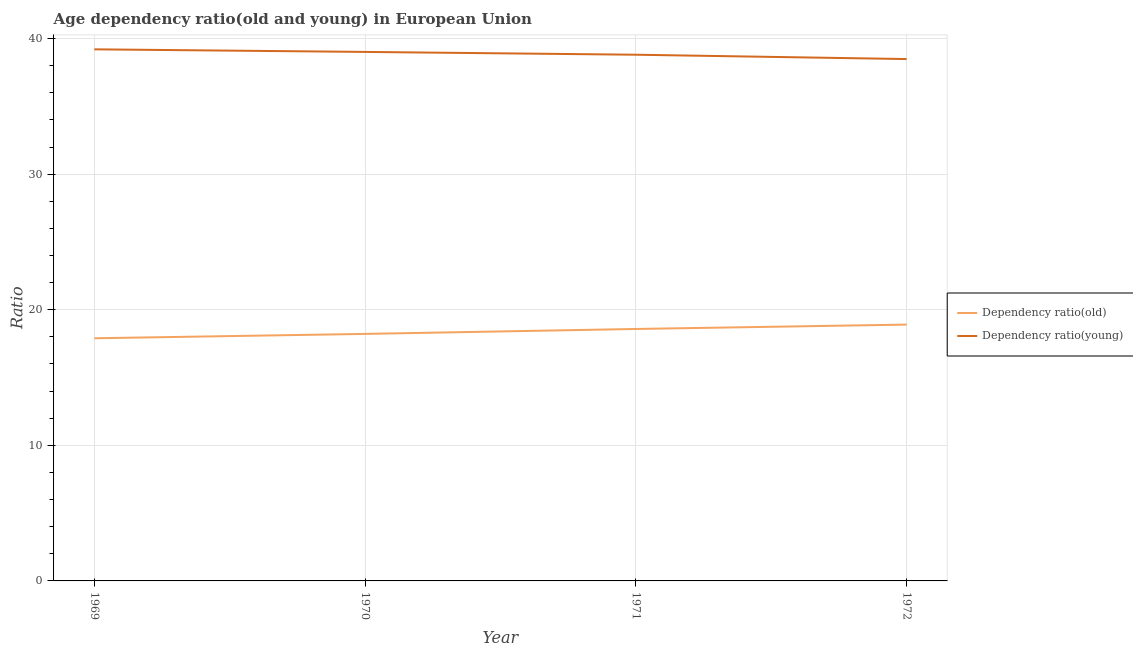Is the number of lines equal to the number of legend labels?
Your response must be concise. Yes. What is the age dependency ratio(old) in 1971?
Ensure brevity in your answer.  18.58. Across all years, what is the maximum age dependency ratio(young)?
Offer a very short reply. 39.21. Across all years, what is the minimum age dependency ratio(old)?
Provide a short and direct response. 17.9. In which year was the age dependency ratio(young) maximum?
Your answer should be very brief. 1969. In which year was the age dependency ratio(old) minimum?
Provide a short and direct response. 1969. What is the total age dependency ratio(old) in the graph?
Provide a succinct answer. 73.6. What is the difference between the age dependency ratio(old) in 1969 and that in 1970?
Offer a very short reply. -0.32. What is the difference between the age dependency ratio(old) in 1972 and the age dependency ratio(young) in 1970?
Give a very brief answer. -20.11. What is the average age dependency ratio(young) per year?
Keep it short and to the point. 38.88. In the year 1972, what is the difference between the age dependency ratio(old) and age dependency ratio(young)?
Give a very brief answer. -19.59. In how many years, is the age dependency ratio(young) greater than 4?
Provide a short and direct response. 4. What is the ratio of the age dependency ratio(old) in 1971 to that in 1972?
Keep it short and to the point. 0.98. Is the difference between the age dependency ratio(old) in 1969 and 1972 greater than the difference between the age dependency ratio(young) in 1969 and 1972?
Your answer should be compact. No. What is the difference between the highest and the second highest age dependency ratio(young)?
Offer a terse response. 0.19. What is the difference between the highest and the lowest age dependency ratio(young)?
Your answer should be compact. 0.72. Is the sum of the age dependency ratio(old) in 1971 and 1972 greater than the maximum age dependency ratio(young) across all years?
Offer a very short reply. No. Does the age dependency ratio(old) monotonically increase over the years?
Offer a terse response. Yes. Is the age dependency ratio(young) strictly greater than the age dependency ratio(old) over the years?
Make the answer very short. Yes. How many years are there in the graph?
Ensure brevity in your answer.  4. What is the difference between two consecutive major ticks on the Y-axis?
Make the answer very short. 10. Where does the legend appear in the graph?
Your answer should be compact. Center right. How many legend labels are there?
Make the answer very short. 2. What is the title of the graph?
Your answer should be very brief. Age dependency ratio(old and young) in European Union. What is the label or title of the Y-axis?
Offer a very short reply. Ratio. What is the Ratio in Dependency ratio(old) in 1969?
Your answer should be very brief. 17.9. What is the Ratio in Dependency ratio(young) in 1969?
Offer a terse response. 39.21. What is the Ratio in Dependency ratio(old) in 1970?
Make the answer very short. 18.22. What is the Ratio in Dependency ratio(young) in 1970?
Keep it short and to the point. 39.02. What is the Ratio of Dependency ratio(old) in 1971?
Make the answer very short. 18.58. What is the Ratio in Dependency ratio(young) in 1971?
Your answer should be very brief. 38.81. What is the Ratio in Dependency ratio(old) in 1972?
Make the answer very short. 18.91. What is the Ratio in Dependency ratio(young) in 1972?
Provide a succinct answer. 38.49. Across all years, what is the maximum Ratio of Dependency ratio(old)?
Make the answer very short. 18.91. Across all years, what is the maximum Ratio of Dependency ratio(young)?
Give a very brief answer. 39.21. Across all years, what is the minimum Ratio of Dependency ratio(old)?
Offer a terse response. 17.9. Across all years, what is the minimum Ratio of Dependency ratio(young)?
Give a very brief answer. 38.49. What is the total Ratio in Dependency ratio(old) in the graph?
Make the answer very short. 73.6. What is the total Ratio of Dependency ratio(young) in the graph?
Ensure brevity in your answer.  155.53. What is the difference between the Ratio of Dependency ratio(old) in 1969 and that in 1970?
Give a very brief answer. -0.32. What is the difference between the Ratio in Dependency ratio(young) in 1969 and that in 1970?
Ensure brevity in your answer.  0.19. What is the difference between the Ratio of Dependency ratio(old) in 1969 and that in 1971?
Ensure brevity in your answer.  -0.69. What is the difference between the Ratio of Dependency ratio(young) in 1969 and that in 1971?
Offer a terse response. 0.4. What is the difference between the Ratio of Dependency ratio(old) in 1969 and that in 1972?
Offer a very short reply. -1.01. What is the difference between the Ratio in Dependency ratio(young) in 1969 and that in 1972?
Ensure brevity in your answer.  0.72. What is the difference between the Ratio of Dependency ratio(old) in 1970 and that in 1971?
Keep it short and to the point. -0.36. What is the difference between the Ratio in Dependency ratio(young) in 1970 and that in 1971?
Keep it short and to the point. 0.21. What is the difference between the Ratio in Dependency ratio(old) in 1970 and that in 1972?
Your answer should be very brief. -0.69. What is the difference between the Ratio of Dependency ratio(young) in 1970 and that in 1972?
Give a very brief answer. 0.53. What is the difference between the Ratio in Dependency ratio(old) in 1971 and that in 1972?
Give a very brief answer. -0.32. What is the difference between the Ratio of Dependency ratio(young) in 1971 and that in 1972?
Offer a very short reply. 0.32. What is the difference between the Ratio of Dependency ratio(old) in 1969 and the Ratio of Dependency ratio(young) in 1970?
Keep it short and to the point. -21.12. What is the difference between the Ratio of Dependency ratio(old) in 1969 and the Ratio of Dependency ratio(young) in 1971?
Give a very brief answer. -20.91. What is the difference between the Ratio in Dependency ratio(old) in 1969 and the Ratio in Dependency ratio(young) in 1972?
Your answer should be very brief. -20.59. What is the difference between the Ratio in Dependency ratio(old) in 1970 and the Ratio in Dependency ratio(young) in 1971?
Make the answer very short. -20.59. What is the difference between the Ratio in Dependency ratio(old) in 1970 and the Ratio in Dependency ratio(young) in 1972?
Your response must be concise. -20.27. What is the difference between the Ratio in Dependency ratio(old) in 1971 and the Ratio in Dependency ratio(young) in 1972?
Provide a short and direct response. -19.91. What is the average Ratio of Dependency ratio(old) per year?
Offer a very short reply. 18.4. What is the average Ratio of Dependency ratio(young) per year?
Ensure brevity in your answer.  38.88. In the year 1969, what is the difference between the Ratio of Dependency ratio(old) and Ratio of Dependency ratio(young)?
Your response must be concise. -21.31. In the year 1970, what is the difference between the Ratio of Dependency ratio(old) and Ratio of Dependency ratio(young)?
Provide a short and direct response. -20.8. In the year 1971, what is the difference between the Ratio of Dependency ratio(old) and Ratio of Dependency ratio(young)?
Your response must be concise. -20.23. In the year 1972, what is the difference between the Ratio in Dependency ratio(old) and Ratio in Dependency ratio(young)?
Your response must be concise. -19.59. What is the ratio of the Ratio of Dependency ratio(old) in 1969 to that in 1970?
Your answer should be compact. 0.98. What is the ratio of the Ratio of Dependency ratio(young) in 1969 to that in 1970?
Make the answer very short. 1. What is the ratio of the Ratio in Dependency ratio(old) in 1969 to that in 1971?
Your answer should be compact. 0.96. What is the ratio of the Ratio in Dependency ratio(young) in 1969 to that in 1971?
Your answer should be compact. 1.01. What is the ratio of the Ratio of Dependency ratio(old) in 1969 to that in 1972?
Your answer should be compact. 0.95. What is the ratio of the Ratio of Dependency ratio(young) in 1969 to that in 1972?
Give a very brief answer. 1.02. What is the ratio of the Ratio of Dependency ratio(old) in 1970 to that in 1971?
Offer a very short reply. 0.98. What is the ratio of the Ratio of Dependency ratio(old) in 1970 to that in 1972?
Your response must be concise. 0.96. What is the ratio of the Ratio in Dependency ratio(young) in 1970 to that in 1972?
Provide a short and direct response. 1.01. What is the ratio of the Ratio in Dependency ratio(old) in 1971 to that in 1972?
Provide a short and direct response. 0.98. What is the ratio of the Ratio in Dependency ratio(young) in 1971 to that in 1972?
Provide a succinct answer. 1.01. What is the difference between the highest and the second highest Ratio in Dependency ratio(old)?
Provide a short and direct response. 0.32. What is the difference between the highest and the second highest Ratio in Dependency ratio(young)?
Give a very brief answer. 0.19. What is the difference between the highest and the lowest Ratio of Dependency ratio(young)?
Give a very brief answer. 0.72. 